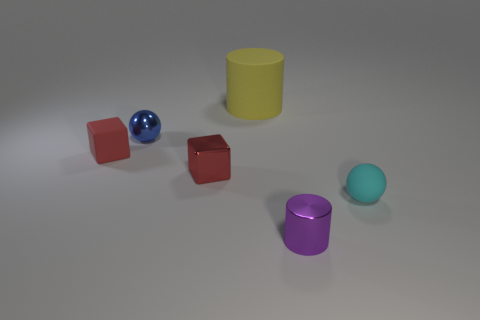What time of day does the lighting in the image suggest? The lighting in the image doesn't suggest a particular time of day as it appears to be a studio setting with controlled lighting. The shadows are short and fall mainly to one side of the objects, indicating a light source that is positioned to the side, perhaps in an effort to mimic afternoon light. However, the lack of environmental context and the uniform grey background make it difficult to determine a specific natural time of day. 